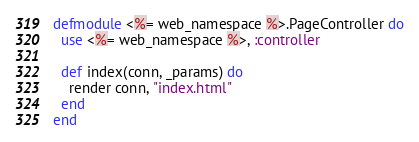<code> <loc_0><loc_0><loc_500><loc_500><_Elixir_>defmodule <%= web_namespace %>.PageController do
  use <%= web_namespace %>, :controller

  def index(conn, _params) do
    render conn, "index.html"
  end
end
</code> 